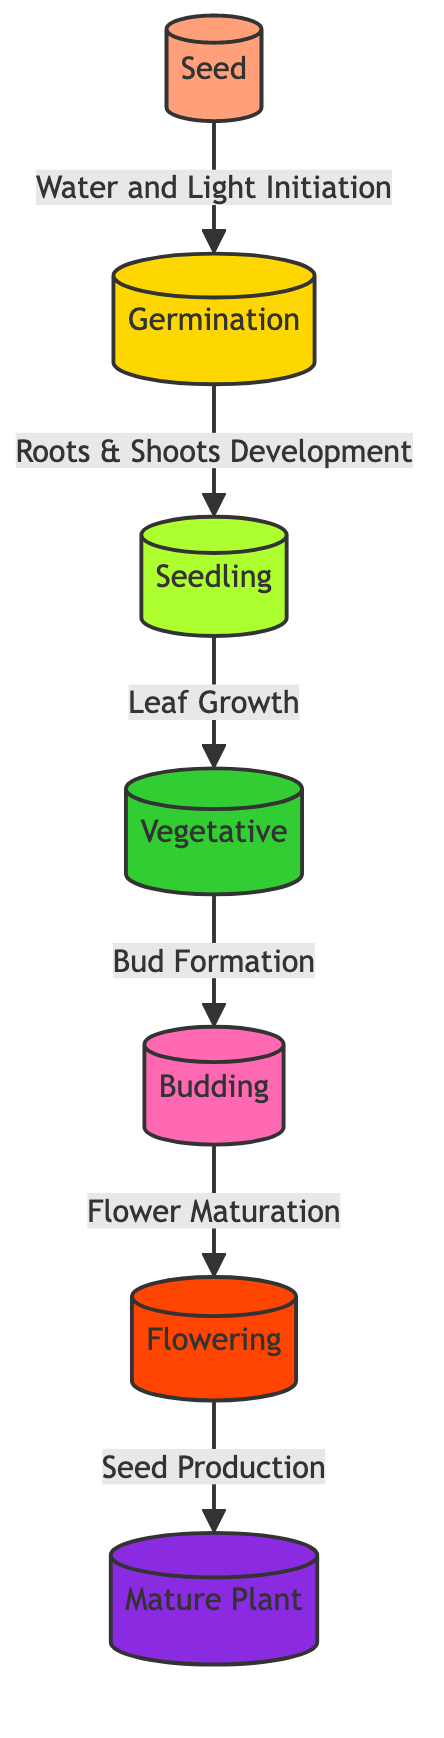What is the first stage of the plant's lifecycle? The diagram clearly labels the first stage as "Seed." This is indicated as the initial node in the flowchart, which is represented by the label in parentheses.
Answer: Seed How many stages are there in total? By counting the nodes in the diagram, we identify seven different stages represented: Seed, Germination, Seedling, Vegetative, Budding, Flowering, and Mature Plant. Therefore, the total number of stages is seven.
Answer: 7 What process follows germination? From the diagram, after Germination, the next stage is Seedling. The arrow connecting Germination to Seedling signifies the direct progression from one stage to another.
Answer: Seedling Which stage is characterized by bud formation? Upon examining the diagram, the fourth stage is labeled "Budding," explicitly indicating that it is during this stage that bud formation occurs, as described by the connecting edge from the Vegetative stage.
Answer: Budding What is the color representing the flowering stage? The color for the Flowering stage is specified in the diagram as #FF4500, which corresponds to a shade of orange. This can also be visually verified from the flowchart where the Flowering node is colored distinctly.
Answer: Orange What is the relationship between the Vegetative stage and Flowering? The diagram shows a direct link from the Vegetative stage to the Flowering stage, illustrating that Flowering is the outcome of the processes initiated during the Vegetative stage, specifically bud formation leading to flowering.
Answer: Direct progression How does a plant reach the mature stage? To become a Mature Plant, the diagram indicates that the final processes involve Flower Maturation and Seed Production. These steps must occur sequentially after the previous stage, thereby resulting in the plant's maturation.
Answer: Through flowering What are the color codes for the seedling stage? The seedling stage is indicated by a specific color code in the diagram, which is defined as a light green shade (#ADFF2F), making it visually distinguishable from other stages.
Answer: Light green 